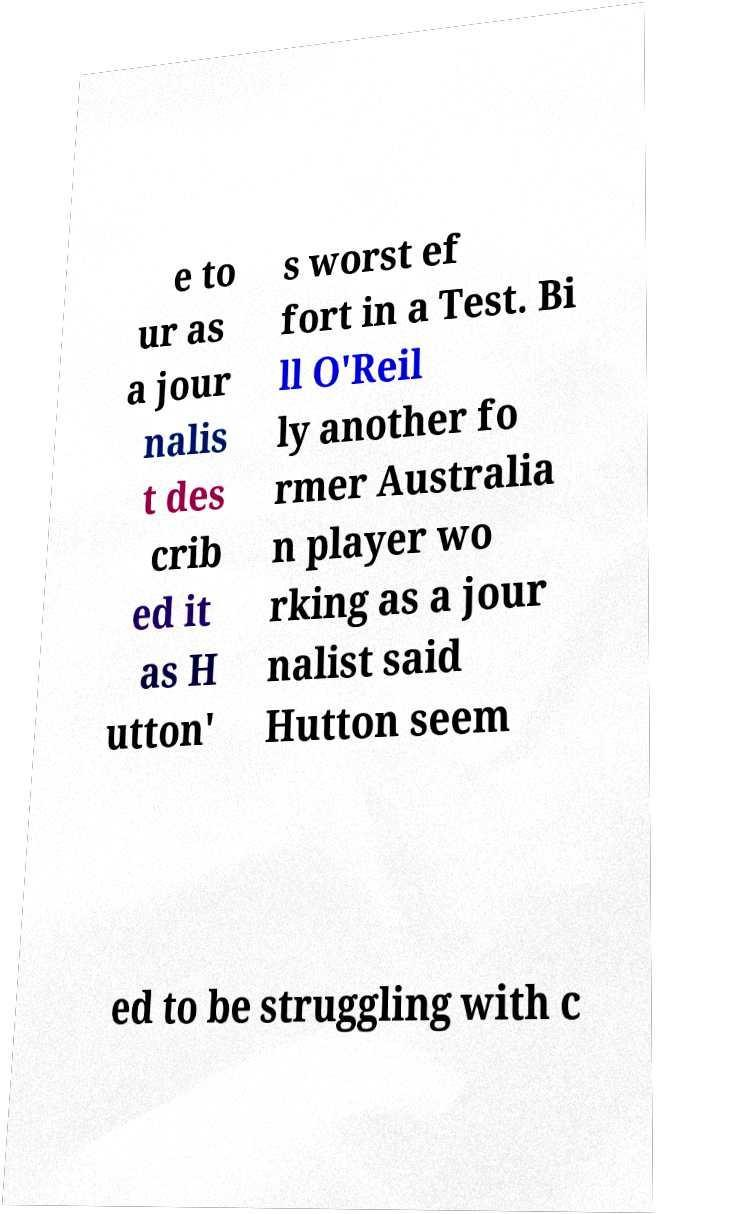What messages or text are displayed in this image? I need them in a readable, typed format. e to ur as a jour nalis t des crib ed it as H utton' s worst ef fort in a Test. Bi ll O'Reil ly another fo rmer Australia n player wo rking as a jour nalist said Hutton seem ed to be struggling with c 